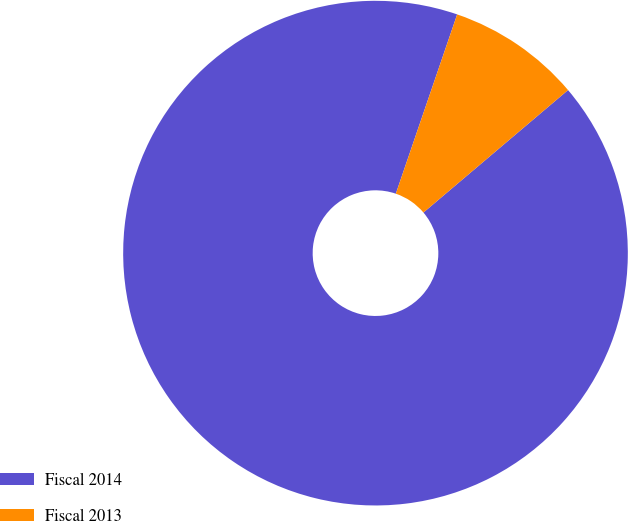Convert chart to OTSL. <chart><loc_0><loc_0><loc_500><loc_500><pie_chart><fcel>Fiscal 2014<fcel>Fiscal 2013<nl><fcel>91.43%<fcel>8.57%<nl></chart> 